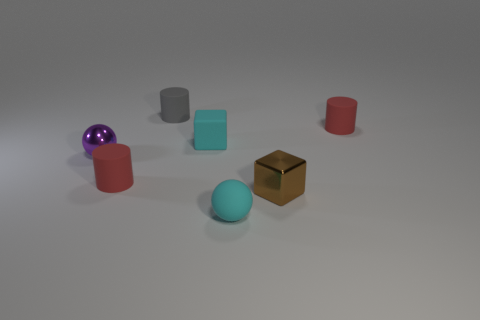What is the lighting condition in the scene? The lighting in the image is soft and diffused, coming from above and creating gentle shadows beneath the objects. This suggests an indoor setting, possibly illuminated by ambient lighting that evenly spreads across the scene. 